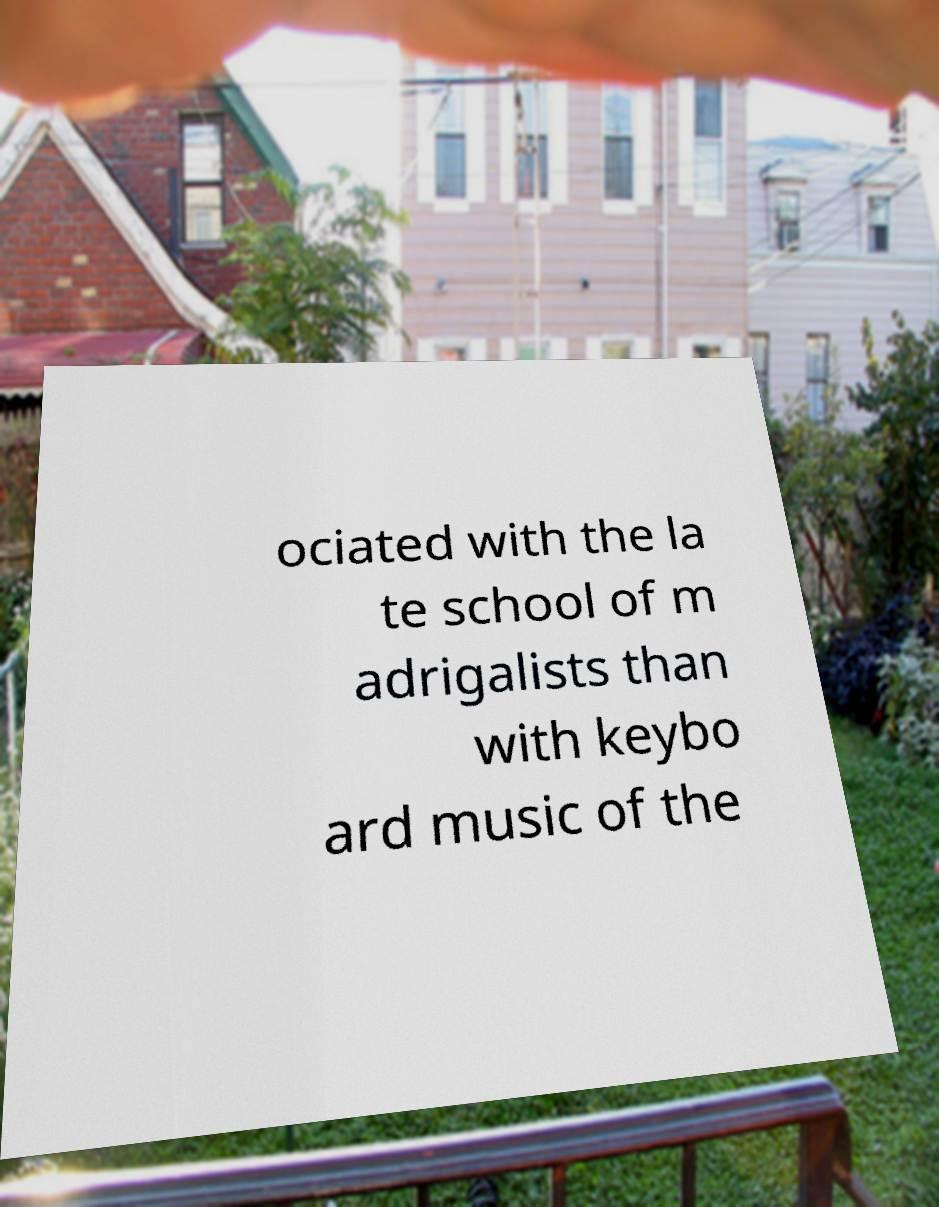For documentation purposes, I need the text within this image transcribed. Could you provide that? ociated with the la te school of m adrigalists than with keybo ard music of the 